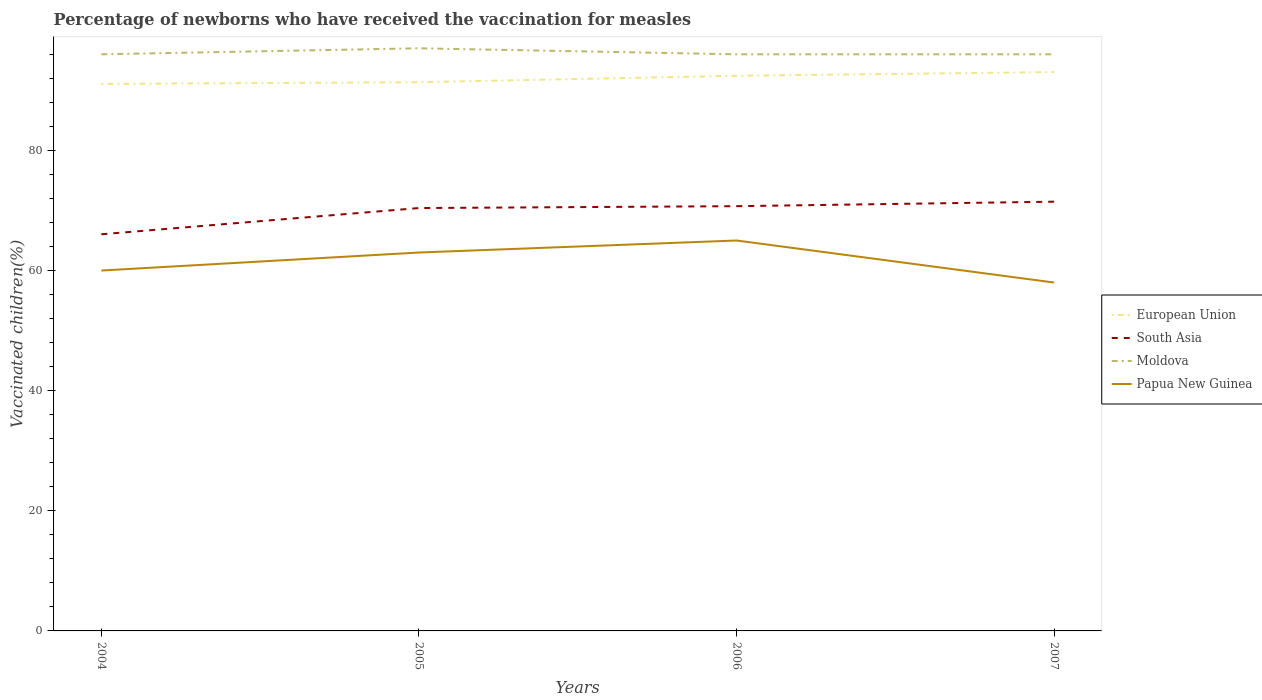Does the line corresponding to Moldova intersect with the line corresponding to European Union?
Your answer should be compact. No. Is the number of lines equal to the number of legend labels?
Ensure brevity in your answer.  Yes. Across all years, what is the maximum percentage of vaccinated children in Papua New Guinea?
Provide a short and direct response. 58. In which year was the percentage of vaccinated children in European Union maximum?
Give a very brief answer. 2004. What is the total percentage of vaccinated children in South Asia in the graph?
Your answer should be very brief. -1.06. What is the difference between the highest and the lowest percentage of vaccinated children in Moldova?
Your answer should be compact. 1. How many lines are there?
Offer a terse response. 4. Are the values on the major ticks of Y-axis written in scientific E-notation?
Your response must be concise. No. Does the graph contain any zero values?
Provide a succinct answer. No. Does the graph contain grids?
Your response must be concise. No. Where does the legend appear in the graph?
Offer a very short reply. Center right. How many legend labels are there?
Provide a succinct answer. 4. What is the title of the graph?
Your answer should be compact. Percentage of newborns who have received the vaccination for measles. Does "Low & middle income" appear as one of the legend labels in the graph?
Provide a succinct answer. No. What is the label or title of the X-axis?
Provide a short and direct response. Years. What is the label or title of the Y-axis?
Give a very brief answer. Vaccinated children(%). What is the Vaccinated children(%) in European Union in 2004?
Your answer should be compact. 91.07. What is the Vaccinated children(%) in South Asia in 2004?
Provide a short and direct response. 66.04. What is the Vaccinated children(%) in Moldova in 2004?
Your answer should be very brief. 96. What is the Vaccinated children(%) in Papua New Guinea in 2004?
Ensure brevity in your answer.  60. What is the Vaccinated children(%) of European Union in 2005?
Make the answer very short. 91.35. What is the Vaccinated children(%) in South Asia in 2005?
Keep it short and to the point. 70.4. What is the Vaccinated children(%) of Moldova in 2005?
Your response must be concise. 97. What is the Vaccinated children(%) in European Union in 2006?
Make the answer very short. 92.43. What is the Vaccinated children(%) of South Asia in 2006?
Offer a terse response. 70.71. What is the Vaccinated children(%) in Moldova in 2006?
Your response must be concise. 96. What is the Vaccinated children(%) of European Union in 2007?
Ensure brevity in your answer.  93.04. What is the Vaccinated children(%) of South Asia in 2007?
Provide a succinct answer. 71.46. What is the Vaccinated children(%) of Moldova in 2007?
Your answer should be compact. 96. What is the Vaccinated children(%) in Papua New Guinea in 2007?
Provide a short and direct response. 58. Across all years, what is the maximum Vaccinated children(%) of European Union?
Provide a succinct answer. 93.04. Across all years, what is the maximum Vaccinated children(%) of South Asia?
Keep it short and to the point. 71.46. Across all years, what is the maximum Vaccinated children(%) in Moldova?
Provide a succinct answer. 97. Across all years, what is the minimum Vaccinated children(%) in European Union?
Your response must be concise. 91.07. Across all years, what is the minimum Vaccinated children(%) of South Asia?
Provide a short and direct response. 66.04. Across all years, what is the minimum Vaccinated children(%) of Moldova?
Keep it short and to the point. 96. What is the total Vaccinated children(%) in European Union in the graph?
Your answer should be compact. 367.89. What is the total Vaccinated children(%) in South Asia in the graph?
Ensure brevity in your answer.  278.62. What is the total Vaccinated children(%) in Moldova in the graph?
Ensure brevity in your answer.  385. What is the total Vaccinated children(%) of Papua New Guinea in the graph?
Provide a succinct answer. 246. What is the difference between the Vaccinated children(%) of European Union in 2004 and that in 2005?
Offer a terse response. -0.28. What is the difference between the Vaccinated children(%) in South Asia in 2004 and that in 2005?
Offer a terse response. -4.37. What is the difference between the Vaccinated children(%) in Moldova in 2004 and that in 2005?
Your answer should be compact. -1. What is the difference between the Vaccinated children(%) in Papua New Guinea in 2004 and that in 2005?
Make the answer very short. -3. What is the difference between the Vaccinated children(%) in European Union in 2004 and that in 2006?
Ensure brevity in your answer.  -1.36. What is the difference between the Vaccinated children(%) of South Asia in 2004 and that in 2006?
Ensure brevity in your answer.  -4.68. What is the difference between the Vaccinated children(%) of Moldova in 2004 and that in 2006?
Offer a very short reply. 0. What is the difference between the Vaccinated children(%) of European Union in 2004 and that in 2007?
Ensure brevity in your answer.  -1.97. What is the difference between the Vaccinated children(%) in South Asia in 2004 and that in 2007?
Your response must be concise. -5.43. What is the difference between the Vaccinated children(%) of European Union in 2005 and that in 2006?
Your answer should be compact. -1.07. What is the difference between the Vaccinated children(%) in South Asia in 2005 and that in 2006?
Your answer should be compact. -0.31. What is the difference between the Vaccinated children(%) of Moldova in 2005 and that in 2006?
Keep it short and to the point. 1. What is the difference between the Vaccinated children(%) in European Union in 2005 and that in 2007?
Give a very brief answer. -1.69. What is the difference between the Vaccinated children(%) in South Asia in 2005 and that in 2007?
Your response must be concise. -1.06. What is the difference between the Vaccinated children(%) in Moldova in 2005 and that in 2007?
Ensure brevity in your answer.  1. What is the difference between the Vaccinated children(%) of European Union in 2006 and that in 2007?
Your answer should be compact. -0.61. What is the difference between the Vaccinated children(%) of South Asia in 2006 and that in 2007?
Provide a short and direct response. -0.75. What is the difference between the Vaccinated children(%) in European Union in 2004 and the Vaccinated children(%) in South Asia in 2005?
Offer a very short reply. 20.66. What is the difference between the Vaccinated children(%) in European Union in 2004 and the Vaccinated children(%) in Moldova in 2005?
Give a very brief answer. -5.93. What is the difference between the Vaccinated children(%) in European Union in 2004 and the Vaccinated children(%) in Papua New Guinea in 2005?
Give a very brief answer. 28.07. What is the difference between the Vaccinated children(%) in South Asia in 2004 and the Vaccinated children(%) in Moldova in 2005?
Your response must be concise. -30.96. What is the difference between the Vaccinated children(%) of South Asia in 2004 and the Vaccinated children(%) of Papua New Guinea in 2005?
Keep it short and to the point. 3.04. What is the difference between the Vaccinated children(%) in Moldova in 2004 and the Vaccinated children(%) in Papua New Guinea in 2005?
Your answer should be compact. 33. What is the difference between the Vaccinated children(%) of European Union in 2004 and the Vaccinated children(%) of South Asia in 2006?
Give a very brief answer. 20.35. What is the difference between the Vaccinated children(%) in European Union in 2004 and the Vaccinated children(%) in Moldova in 2006?
Your answer should be compact. -4.93. What is the difference between the Vaccinated children(%) of European Union in 2004 and the Vaccinated children(%) of Papua New Guinea in 2006?
Your answer should be very brief. 26.07. What is the difference between the Vaccinated children(%) of South Asia in 2004 and the Vaccinated children(%) of Moldova in 2006?
Provide a short and direct response. -29.96. What is the difference between the Vaccinated children(%) in South Asia in 2004 and the Vaccinated children(%) in Papua New Guinea in 2006?
Make the answer very short. 1.04. What is the difference between the Vaccinated children(%) in European Union in 2004 and the Vaccinated children(%) in South Asia in 2007?
Offer a very short reply. 19.61. What is the difference between the Vaccinated children(%) of European Union in 2004 and the Vaccinated children(%) of Moldova in 2007?
Provide a short and direct response. -4.93. What is the difference between the Vaccinated children(%) of European Union in 2004 and the Vaccinated children(%) of Papua New Guinea in 2007?
Make the answer very short. 33.07. What is the difference between the Vaccinated children(%) in South Asia in 2004 and the Vaccinated children(%) in Moldova in 2007?
Offer a very short reply. -29.96. What is the difference between the Vaccinated children(%) in South Asia in 2004 and the Vaccinated children(%) in Papua New Guinea in 2007?
Your answer should be very brief. 8.04. What is the difference between the Vaccinated children(%) in European Union in 2005 and the Vaccinated children(%) in South Asia in 2006?
Your response must be concise. 20.64. What is the difference between the Vaccinated children(%) of European Union in 2005 and the Vaccinated children(%) of Moldova in 2006?
Your answer should be compact. -4.65. What is the difference between the Vaccinated children(%) of European Union in 2005 and the Vaccinated children(%) of Papua New Guinea in 2006?
Provide a short and direct response. 26.35. What is the difference between the Vaccinated children(%) in South Asia in 2005 and the Vaccinated children(%) in Moldova in 2006?
Provide a short and direct response. -25.6. What is the difference between the Vaccinated children(%) in South Asia in 2005 and the Vaccinated children(%) in Papua New Guinea in 2006?
Make the answer very short. 5.4. What is the difference between the Vaccinated children(%) in Moldova in 2005 and the Vaccinated children(%) in Papua New Guinea in 2006?
Your response must be concise. 32. What is the difference between the Vaccinated children(%) in European Union in 2005 and the Vaccinated children(%) in South Asia in 2007?
Offer a terse response. 19.89. What is the difference between the Vaccinated children(%) in European Union in 2005 and the Vaccinated children(%) in Moldova in 2007?
Provide a succinct answer. -4.65. What is the difference between the Vaccinated children(%) of European Union in 2005 and the Vaccinated children(%) of Papua New Guinea in 2007?
Your answer should be compact. 33.35. What is the difference between the Vaccinated children(%) in South Asia in 2005 and the Vaccinated children(%) in Moldova in 2007?
Provide a short and direct response. -25.6. What is the difference between the Vaccinated children(%) in South Asia in 2005 and the Vaccinated children(%) in Papua New Guinea in 2007?
Provide a short and direct response. 12.4. What is the difference between the Vaccinated children(%) in European Union in 2006 and the Vaccinated children(%) in South Asia in 2007?
Keep it short and to the point. 20.96. What is the difference between the Vaccinated children(%) in European Union in 2006 and the Vaccinated children(%) in Moldova in 2007?
Your answer should be very brief. -3.57. What is the difference between the Vaccinated children(%) of European Union in 2006 and the Vaccinated children(%) of Papua New Guinea in 2007?
Ensure brevity in your answer.  34.43. What is the difference between the Vaccinated children(%) of South Asia in 2006 and the Vaccinated children(%) of Moldova in 2007?
Offer a terse response. -25.29. What is the difference between the Vaccinated children(%) in South Asia in 2006 and the Vaccinated children(%) in Papua New Guinea in 2007?
Ensure brevity in your answer.  12.71. What is the average Vaccinated children(%) in European Union per year?
Your answer should be compact. 91.97. What is the average Vaccinated children(%) of South Asia per year?
Make the answer very short. 69.65. What is the average Vaccinated children(%) of Moldova per year?
Offer a very short reply. 96.25. What is the average Vaccinated children(%) of Papua New Guinea per year?
Your response must be concise. 61.5. In the year 2004, what is the difference between the Vaccinated children(%) in European Union and Vaccinated children(%) in South Asia?
Make the answer very short. 25.03. In the year 2004, what is the difference between the Vaccinated children(%) in European Union and Vaccinated children(%) in Moldova?
Give a very brief answer. -4.93. In the year 2004, what is the difference between the Vaccinated children(%) of European Union and Vaccinated children(%) of Papua New Guinea?
Your answer should be compact. 31.07. In the year 2004, what is the difference between the Vaccinated children(%) of South Asia and Vaccinated children(%) of Moldova?
Offer a very short reply. -29.96. In the year 2004, what is the difference between the Vaccinated children(%) in South Asia and Vaccinated children(%) in Papua New Guinea?
Provide a short and direct response. 6.04. In the year 2005, what is the difference between the Vaccinated children(%) in European Union and Vaccinated children(%) in South Asia?
Your answer should be very brief. 20.95. In the year 2005, what is the difference between the Vaccinated children(%) in European Union and Vaccinated children(%) in Moldova?
Offer a very short reply. -5.65. In the year 2005, what is the difference between the Vaccinated children(%) in European Union and Vaccinated children(%) in Papua New Guinea?
Keep it short and to the point. 28.35. In the year 2005, what is the difference between the Vaccinated children(%) of South Asia and Vaccinated children(%) of Moldova?
Your answer should be very brief. -26.6. In the year 2005, what is the difference between the Vaccinated children(%) in South Asia and Vaccinated children(%) in Papua New Guinea?
Keep it short and to the point. 7.4. In the year 2006, what is the difference between the Vaccinated children(%) of European Union and Vaccinated children(%) of South Asia?
Provide a short and direct response. 21.71. In the year 2006, what is the difference between the Vaccinated children(%) in European Union and Vaccinated children(%) in Moldova?
Ensure brevity in your answer.  -3.57. In the year 2006, what is the difference between the Vaccinated children(%) in European Union and Vaccinated children(%) in Papua New Guinea?
Provide a succinct answer. 27.43. In the year 2006, what is the difference between the Vaccinated children(%) of South Asia and Vaccinated children(%) of Moldova?
Give a very brief answer. -25.29. In the year 2006, what is the difference between the Vaccinated children(%) of South Asia and Vaccinated children(%) of Papua New Guinea?
Ensure brevity in your answer.  5.71. In the year 2006, what is the difference between the Vaccinated children(%) of Moldova and Vaccinated children(%) of Papua New Guinea?
Offer a terse response. 31. In the year 2007, what is the difference between the Vaccinated children(%) in European Union and Vaccinated children(%) in South Asia?
Ensure brevity in your answer.  21.58. In the year 2007, what is the difference between the Vaccinated children(%) of European Union and Vaccinated children(%) of Moldova?
Your answer should be very brief. -2.96. In the year 2007, what is the difference between the Vaccinated children(%) of European Union and Vaccinated children(%) of Papua New Guinea?
Give a very brief answer. 35.04. In the year 2007, what is the difference between the Vaccinated children(%) of South Asia and Vaccinated children(%) of Moldova?
Your answer should be compact. -24.54. In the year 2007, what is the difference between the Vaccinated children(%) of South Asia and Vaccinated children(%) of Papua New Guinea?
Offer a terse response. 13.46. What is the ratio of the Vaccinated children(%) in South Asia in 2004 to that in 2005?
Make the answer very short. 0.94. What is the ratio of the Vaccinated children(%) of Moldova in 2004 to that in 2005?
Offer a very short reply. 0.99. What is the ratio of the Vaccinated children(%) in Papua New Guinea in 2004 to that in 2005?
Ensure brevity in your answer.  0.95. What is the ratio of the Vaccinated children(%) of South Asia in 2004 to that in 2006?
Offer a terse response. 0.93. What is the ratio of the Vaccinated children(%) in Moldova in 2004 to that in 2006?
Provide a succinct answer. 1. What is the ratio of the Vaccinated children(%) in Papua New Guinea in 2004 to that in 2006?
Your answer should be compact. 0.92. What is the ratio of the Vaccinated children(%) in European Union in 2004 to that in 2007?
Offer a very short reply. 0.98. What is the ratio of the Vaccinated children(%) of South Asia in 2004 to that in 2007?
Ensure brevity in your answer.  0.92. What is the ratio of the Vaccinated children(%) of Papua New Guinea in 2004 to that in 2007?
Your answer should be compact. 1.03. What is the ratio of the Vaccinated children(%) of European Union in 2005 to that in 2006?
Offer a very short reply. 0.99. What is the ratio of the Vaccinated children(%) in Moldova in 2005 to that in 2006?
Your response must be concise. 1.01. What is the ratio of the Vaccinated children(%) of Papua New Guinea in 2005 to that in 2006?
Provide a short and direct response. 0.97. What is the ratio of the Vaccinated children(%) of European Union in 2005 to that in 2007?
Provide a short and direct response. 0.98. What is the ratio of the Vaccinated children(%) in South Asia in 2005 to that in 2007?
Provide a succinct answer. 0.99. What is the ratio of the Vaccinated children(%) in Moldova in 2005 to that in 2007?
Your response must be concise. 1.01. What is the ratio of the Vaccinated children(%) of Papua New Guinea in 2005 to that in 2007?
Provide a short and direct response. 1.09. What is the ratio of the Vaccinated children(%) of Moldova in 2006 to that in 2007?
Offer a terse response. 1. What is the ratio of the Vaccinated children(%) in Papua New Guinea in 2006 to that in 2007?
Provide a short and direct response. 1.12. What is the difference between the highest and the second highest Vaccinated children(%) of European Union?
Provide a succinct answer. 0.61. What is the difference between the highest and the second highest Vaccinated children(%) of South Asia?
Provide a succinct answer. 0.75. What is the difference between the highest and the second highest Vaccinated children(%) in Moldova?
Offer a terse response. 1. What is the difference between the highest and the lowest Vaccinated children(%) of European Union?
Make the answer very short. 1.97. What is the difference between the highest and the lowest Vaccinated children(%) in South Asia?
Make the answer very short. 5.43. What is the difference between the highest and the lowest Vaccinated children(%) of Moldova?
Keep it short and to the point. 1. 